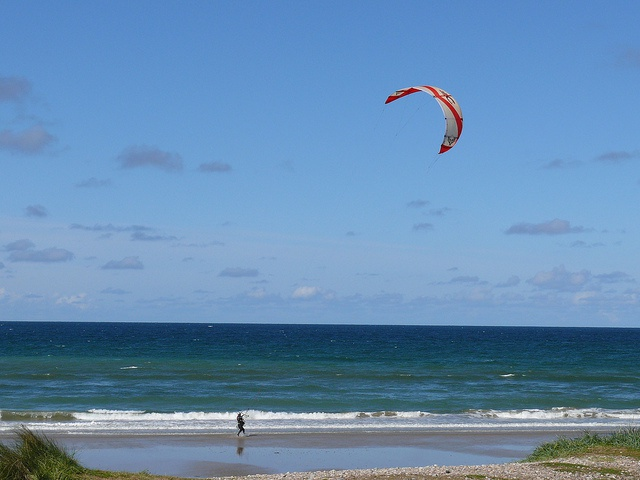Describe the objects in this image and their specific colors. I can see kite in gray, darkgray, brown, and maroon tones and people in gray, black, and darkgray tones in this image. 